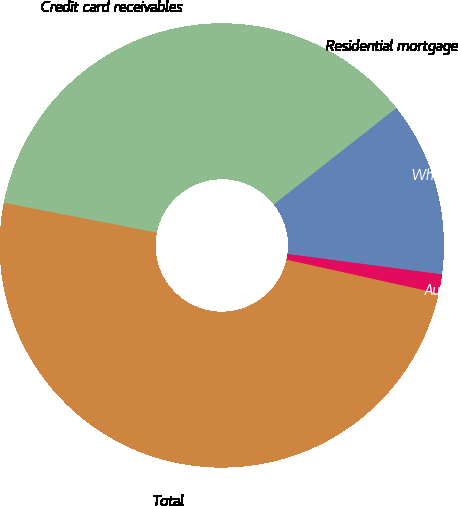<chart> <loc_0><loc_0><loc_500><loc_500><pie_chart><fcel>Credit card receivables<fcel>Residential mortgage<fcel>Wholesale activities<fcel>Automobile loans<fcel>Total<nl><fcel>30.11%<fcel>6.21%<fcel>12.69%<fcel>1.39%<fcel>49.6%<nl></chart> 